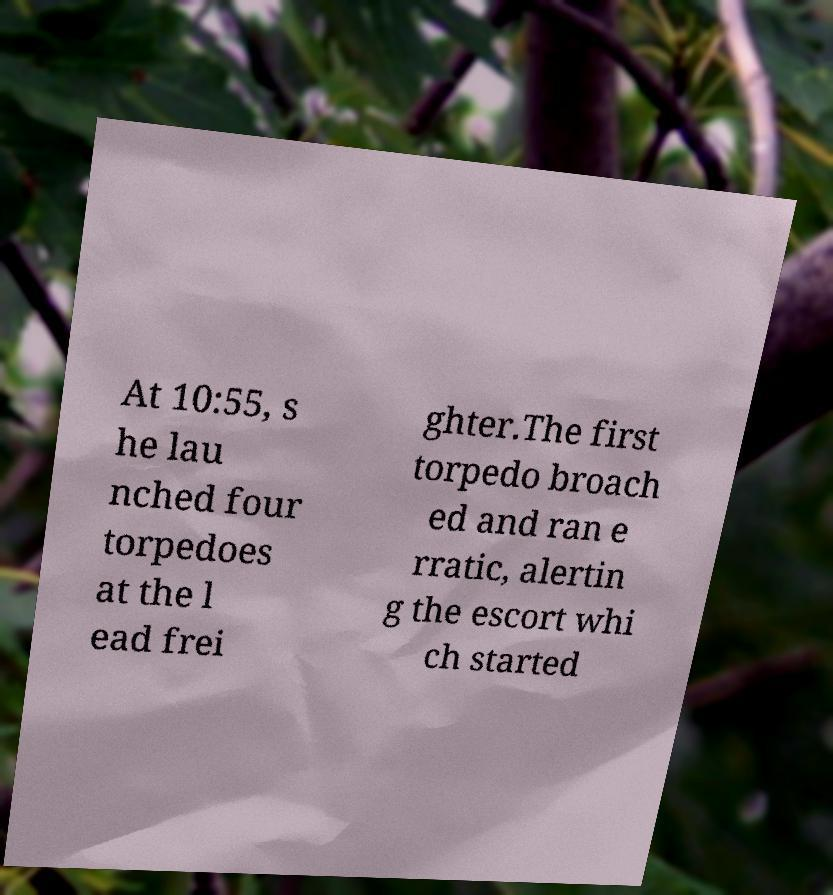Can you accurately transcribe the text from the provided image for me? At 10:55, s he lau nched four torpedoes at the l ead frei ghter.The first torpedo broach ed and ran e rratic, alertin g the escort whi ch started 